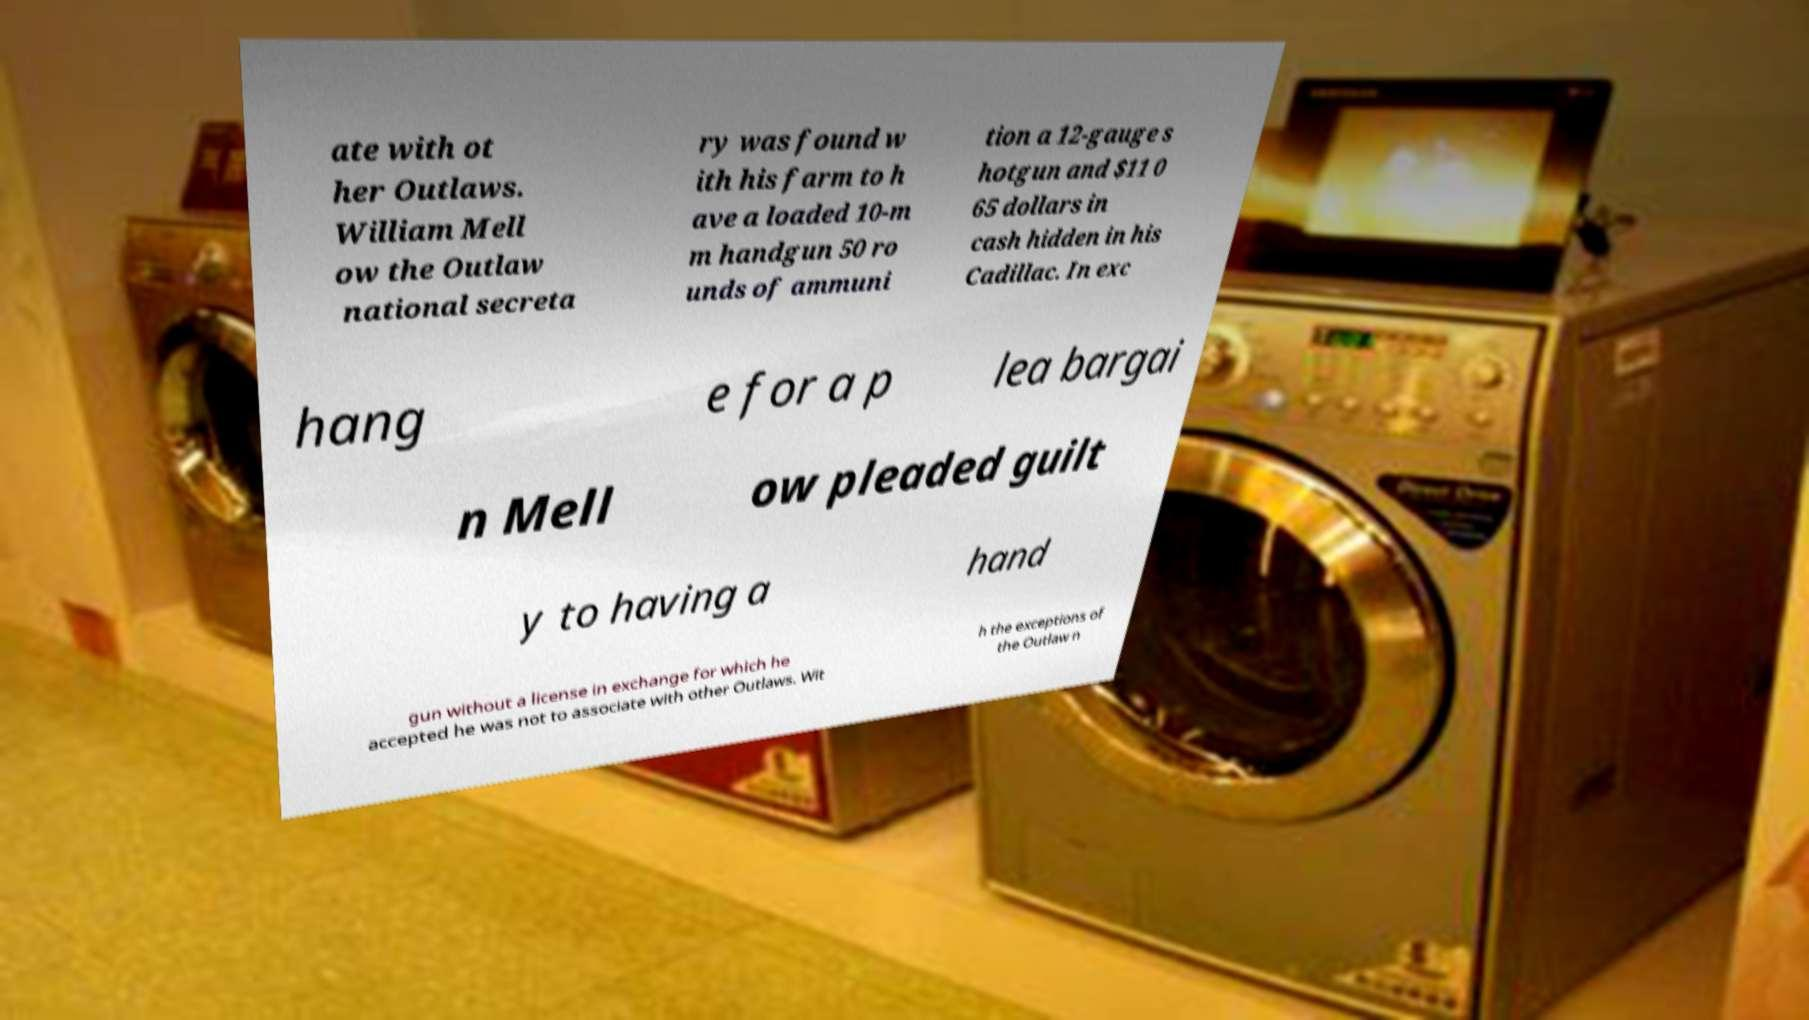Can you read and provide the text displayed in the image?This photo seems to have some interesting text. Can you extract and type it out for me? ate with ot her Outlaws. William Mell ow the Outlaw national secreta ry was found w ith his farm to h ave a loaded 10-m m handgun 50 ro unds of ammuni tion a 12-gauge s hotgun and $11 0 65 dollars in cash hidden in his Cadillac. In exc hang e for a p lea bargai n Mell ow pleaded guilt y to having a hand gun without a license in exchange for which he accepted he was not to associate with other Outlaws. Wit h the exceptions of the Outlaw n 